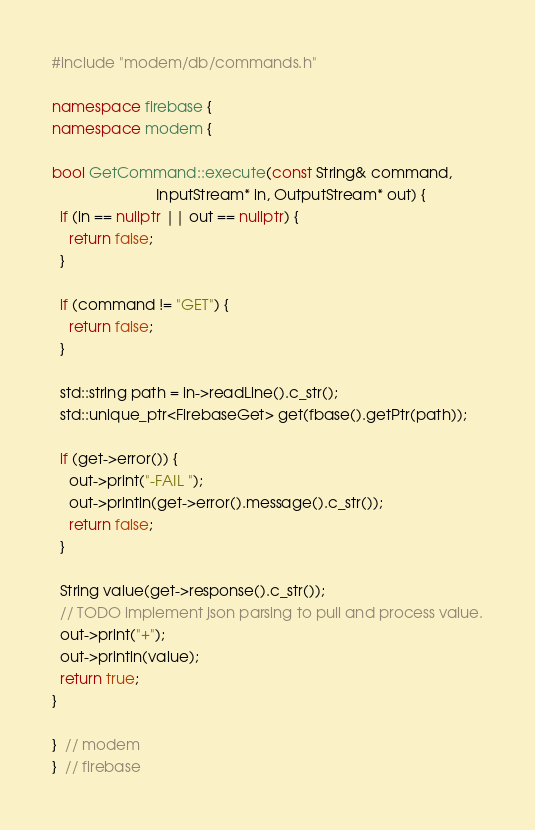<code> <loc_0><loc_0><loc_500><loc_500><_C++_>#include "modem/db/commands.h"

namespace firebase {
namespace modem {

bool GetCommand::execute(const String& command,
                         InputStream* in, OutputStream* out) {
  if (in == nullptr || out == nullptr) {
    return false;
  }

  if (command != "GET") {
    return false;
  }

  std::string path = in->readLine().c_str();
  std::unique_ptr<FirebaseGet> get(fbase().getPtr(path));

  if (get->error()) {
    out->print("-FAIL ");
    out->println(get->error().message().c_str());
    return false;
  }

  String value(get->response().c_str());
  // TODO implement json parsing to pull and process value.
  out->print("+");
  out->println(value);
  return true;
}

}  // modem
}  // firebase
</code> 